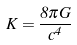<formula> <loc_0><loc_0><loc_500><loc_500>K = \frac { 8 \pi G } { c ^ { 4 } }</formula> 